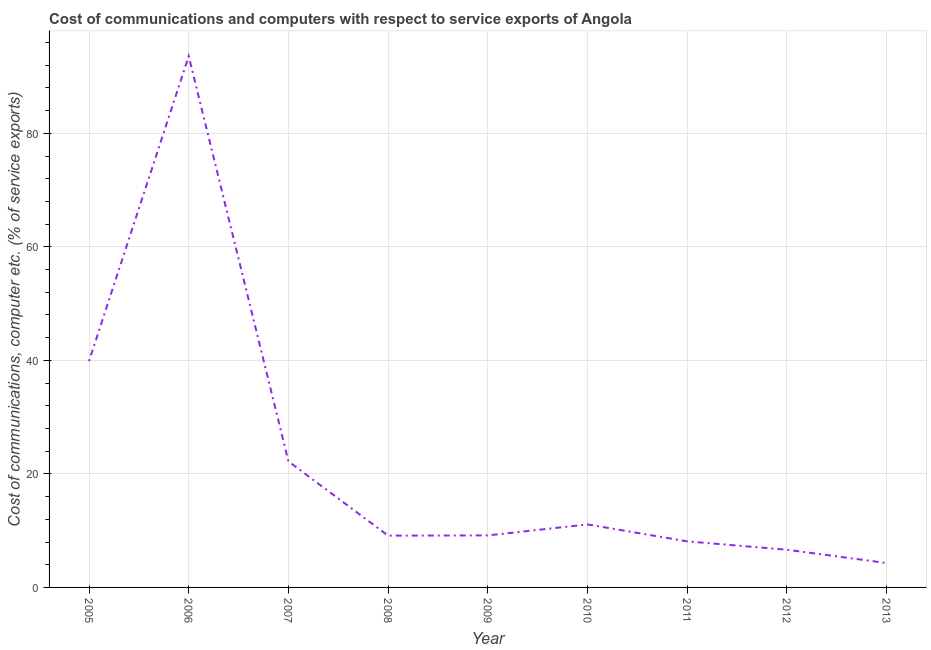What is the cost of communications and computer in 2012?
Keep it short and to the point. 6.64. Across all years, what is the maximum cost of communications and computer?
Provide a short and direct response. 93.59. Across all years, what is the minimum cost of communications and computer?
Your answer should be very brief. 4.3. In which year was the cost of communications and computer maximum?
Ensure brevity in your answer.  2006. In which year was the cost of communications and computer minimum?
Give a very brief answer. 2013. What is the sum of the cost of communications and computer?
Your response must be concise. 204.12. What is the difference between the cost of communications and computer in 2006 and 2009?
Keep it short and to the point. 84.43. What is the average cost of communications and computer per year?
Keep it short and to the point. 22.68. What is the median cost of communications and computer?
Your answer should be very brief. 9.17. In how many years, is the cost of communications and computer greater than 48 %?
Give a very brief answer. 1. Do a majority of the years between 2005 and 2007 (inclusive) have cost of communications and computer greater than 4 %?
Your answer should be compact. Yes. What is the ratio of the cost of communications and computer in 2006 to that in 2009?
Your response must be concise. 10.21. Is the cost of communications and computer in 2007 less than that in 2011?
Make the answer very short. No. Is the difference between the cost of communications and computer in 2006 and 2009 greater than the difference between any two years?
Ensure brevity in your answer.  No. What is the difference between the highest and the second highest cost of communications and computer?
Ensure brevity in your answer.  53.72. What is the difference between the highest and the lowest cost of communications and computer?
Provide a short and direct response. 89.3. In how many years, is the cost of communications and computer greater than the average cost of communications and computer taken over all years?
Ensure brevity in your answer.  2. How many lines are there?
Give a very brief answer. 1. How many years are there in the graph?
Offer a very short reply. 9. What is the difference between two consecutive major ticks on the Y-axis?
Provide a succinct answer. 20. Are the values on the major ticks of Y-axis written in scientific E-notation?
Ensure brevity in your answer.  No. Does the graph contain any zero values?
Offer a terse response. No. Does the graph contain grids?
Provide a succinct answer. Yes. What is the title of the graph?
Your answer should be compact. Cost of communications and computers with respect to service exports of Angola. What is the label or title of the Y-axis?
Provide a succinct answer. Cost of communications, computer etc. (% of service exports). What is the Cost of communications, computer etc. (% of service exports) in 2005?
Keep it short and to the point. 39.88. What is the Cost of communications, computer etc. (% of service exports) in 2006?
Ensure brevity in your answer.  93.59. What is the Cost of communications, computer etc. (% of service exports) of 2007?
Provide a succinct answer. 22.21. What is the Cost of communications, computer etc. (% of service exports) of 2008?
Your answer should be very brief. 9.12. What is the Cost of communications, computer etc. (% of service exports) of 2009?
Offer a terse response. 9.17. What is the Cost of communications, computer etc. (% of service exports) in 2010?
Offer a very short reply. 11.1. What is the Cost of communications, computer etc. (% of service exports) in 2011?
Keep it short and to the point. 8.11. What is the Cost of communications, computer etc. (% of service exports) in 2012?
Provide a succinct answer. 6.64. What is the Cost of communications, computer etc. (% of service exports) in 2013?
Ensure brevity in your answer.  4.3. What is the difference between the Cost of communications, computer etc. (% of service exports) in 2005 and 2006?
Keep it short and to the point. -53.72. What is the difference between the Cost of communications, computer etc. (% of service exports) in 2005 and 2007?
Offer a terse response. 17.66. What is the difference between the Cost of communications, computer etc. (% of service exports) in 2005 and 2008?
Offer a very short reply. 30.75. What is the difference between the Cost of communications, computer etc. (% of service exports) in 2005 and 2009?
Make the answer very short. 30.71. What is the difference between the Cost of communications, computer etc. (% of service exports) in 2005 and 2010?
Offer a very short reply. 28.78. What is the difference between the Cost of communications, computer etc. (% of service exports) in 2005 and 2011?
Keep it short and to the point. 31.76. What is the difference between the Cost of communications, computer etc. (% of service exports) in 2005 and 2012?
Your answer should be very brief. 33.23. What is the difference between the Cost of communications, computer etc. (% of service exports) in 2005 and 2013?
Ensure brevity in your answer.  35.58. What is the difference between the Cost of communications, computer etc. (% of service exports) in 2006 and 2007?
Provide a succinct answer. 71.38. What is the difference between the Cost of communications, computer etc. (% of service exports) in 2006 and 2008?
Provide a short and direct response. 84.47. What is the difference between the Cost of communications, computer etc. (% of service exports) in 2006 and 2009?
Ensure brevity in your answer.  84.43. What is the difference between the Cost of communications, computer etc. (% of service exports) in 2006 and 2010?
Ensure brevity in your answer.  82.49. What is the difference between the Cost of communications, computer etc. (% of service exports) in 2006 and 2011?
Your answer should be very brief. 85.48. What is the difference between the Cost of communications, computer etc. (% of service exports) in 2006 and 2012?
Make the answer very short. 86.95. What is the difference between the Cost of communications, computer etc. (% of service exports) in 2006 and 2013?
Your answer should be very brief. 89.3. What is the difference between the Cost of communications, computer etc. (% of service exports) in 2007 and 2008?
Provide a short and direct response. 13.09. What is the difference between the Cost of communications, computer etc. (% of service exports) in 2007 and 2009?
Make the answer very short. 13.05. What is the difference between the Cost of communications, computer etc. (% of service exports) in 2007 and 2010?
Offer a very short reply. 11.11. What is the difference between the Cost of communications, computer etc. (% of service exports) in 2007 and 2011?
Your answer should be very brief. 14.1. What is the difference between the Cost of communications, computer etc. (% of service exports) in 2007 and 2012?
Offer a terse response. 15.57. What is the difference between the Cost of communications, computer etc. (% of service exports) in 2007 and 2013?
Ensure brevity in your answer.  17.92. What is the difference between the Cost of communications, computer etc. (% of service exports) in 2008 and 2009?
Give a very brief answer. -0.04. What is the difference between the Cost of communications, computer etc. (% of service exports) in 2008 and 2010?
Ensure brevity in your answer.  -1.98. What is the difference between the Cost of communications, computer etc. (% of service exports) in 2008 and 2011?
Keep it short and to the point. 1.01. What is the difference between the Cost of communications, computer etc. (% of service exports) in 2008 and 2012?
Give a very brief answer. 2.48. What is the difference between the Cost of communications, computer etc. (% of service exports) in 2008 and 2013?
Your response must be concise. 4.82. What is the difference between the Cost of communications, computer etc. (% of service exports) in 2009 and 2010?
Ensure brevity in your answer.  -1.93. What is the difference between the Cost of communications, computer etc. (% of service exports) in 2009 and 2011?
Keep it short and to the point. 1.05. What is the difference between the Cost of communications, computer etc. (% of service exports) in 2009 and 2012?
Your answer should be very brief. 2.52. What is the difference between the Cost of communications, computer etc. (% of service exports) in 2009 and 2013?
Offer a terse response. 4.87. What is the difference between the Cost of communications, computer etc. (% of service exports) in 2010 and 2011?
Provide a succinct answer. 2.98. What is the difference between the Cost of communications, computer etc. (% of service exports) in 2010 and 2012?
Offer a very short reply. 4.46. What is the difference between the Cost of communications, computer etc. (% of service exports) in 2010 and 2013?
Your response must be concise. 6.8. What is the difference between the Cost of communications, computer etc. (% of service exports) in 2011 and 2012?
Make the answer very short. 1.47. What is the difference between the Cost of communications, computer etc. (% of service exports) in 2011 and 2013?
Your response must be concise. 3.82. What is the difference between the Cost of communications, computer etc. (% of service exports) in 2012 and 2013?
Provide a short and direct response. 2.34. What is the ratio of the Cost of communications, computer etc. (% of service exports) in 2005 to that in 2006?
Give a very brief answer. 0.43. What is the ratio of the Cost of communications, computer etc. (% of service exports) in 2005 to that in 2007?
Give a very brief answer. 1.79. What is the ratio of the Cost of communications, computer etc. (% of service exports) in 2005 to that in 2008?
Your answer should be very brief. 4.37. What is the ratio of the Cost of communications, computer etc. (% of service exports) in 2005 to that in 2009?
Your response must be concise. 4.35. What is the ratio of the Cost of communications, computer etc. (% of service exports) in 2005 to that in 2010?
Your answer should be very brief. 3.59. What is the ratio of the Cost of communications, computer etc. (% of service exports) in 2005 to that in 2011?
Your answer should be very brief. 4.91. What is the ratio of the Cost of communications, computer etc. (% of service exports) in 2005 to that in 2012?
Offer a terse response. 6. What is the ratio of the Cost of communications, computer etc. (% of service exports) in 2005 to that in 2013?
Offer a terse response. 9.28. What is the ratio of the Cost of communications, computer etc. (% of service exports) in 2006 to that in 2007?
Your response must be concise. 4.21. What is the ratio of the Cost of communications, computer etc. (% of service exports) in 2006 to that in 2008?
Your answer should be compact. 10.26. What is the ratio of the Cost of communications, computer etc. (% of service exports) in 2006 to that in 2009?
Provide a short and direct response. 10.21. What is the ratio of the Cost of communications, computer etc. (% of service exports) in 2006 to that in 2010?
Offer a very short reply. 8.43. What is the ratio of the Cost of communications, computer etc. (% of service exports) in 2006 to that in 2011?
Offer a very short reply. 11.53. What is the ratio of the Cost of communications, computer etc. (% of service exports) in 2006 to that in 2012?
Offer a terse response. 14.09. What is the ratio of the Cost of communications, computer etc. (% of service exports) in 2006 to that in 2013?
Make the answer very short. 21.78. What is the ratio of the Cost of communications, computer etc. (% of service exports) in 2007 to that in 2008?
Give a very brief answer. 2.44. What is the ratio of the Cost of communications, computer etc. (% of service exports) in 2007 to that in 2009?
Offer a very short reply. 2.42. What is the ratio of the Cost of communications, computer etc. (% of service exports) in 2007 to that in 2010?
Make the answer very short. 2. What is the ratio of the Cost of communications, computer etc. (% of service exports) in 2007 to that in 2011?
Offer a terse response. 2.74. What is the ratio of the Cost of communications, computer etc. (% of service exports) in 2007 to that in 2012?
Offer a very short reply. 3.35. What is the ratio of the Cost of communications, computer etc. (% of service exports) in 2007 to that in 2013?
Make the answer very short. 5.17. What is the ratio of the Cost of communications, computer etc. (% of service exports) in 2008 to that in 2009?
Your answer should be very brief. 0.99. What is the ratio of the Cost of communications, computer etc. (% of service exports) in 2008 to that in 2010?
Keep it short and to the point. 0.82. What is the ratio of the Cost of communications, computer etc. (% of service exports) in 2008 to that in 2011?
Give a very brief answer. 1.12. What is the ratio of the Cost of communications, computer etc. (% of service exports) in 2008 to that in 2012?
Ensure brevity in your answer.  1.37. What is the ratio of the Cost of communications, computer etc. (% of service exports) in 2008 to that in 2013?
Provide a short and direct response. 2.12. What is the ratio of the Cost of communications, computer etc. (% of service exports) in 2009 to that in 2010?
Provide a succinct answer. 0.83. What is the ratio of the Cost of communications, computer etc. (% of service exports) in 2009 to that in 2011?
Offer a terse response. 1.13. What is the ratio of the Cost of communications, computer etc. (% of service exports) in 2009 to that in 2012?
Provide a succinct answer. 1.38. What is the ratio of the Cost of communications, computer etc. (% of service exports) in 2009 to that in 2013?
Make the answer very short. 2.13. What is the ratio of the Cost of communications, computer etc. (% of service exports) in 2010 to that in 2011?
Provide a succinct answer. 1.37. What is the ratio of the Cost of communications, computer etc. (% of service exports) in 2010 to that in 2012?
Provide a succinct answer. 1.67. What is the ratio of the Cost of communications, computer etc. (% of service exports) in 2010 to that in 2013?
Keep it short and to the point. 2.58. What is the ratio of the Cost of communications, computer etc. (% of service exports) in 2011 to that in 2012?
Offer a terse response. 1.22. What is the ratio of the Cost of communications, computer etc. (% of service exports) in 2011 to that in 2013?
Keep it short and to the point. 1.89. What is the ratio of the Cost of communications, computer etc. (% of service exports) in 2012 to that in 2013?
Offer a terse response. 1.54. 